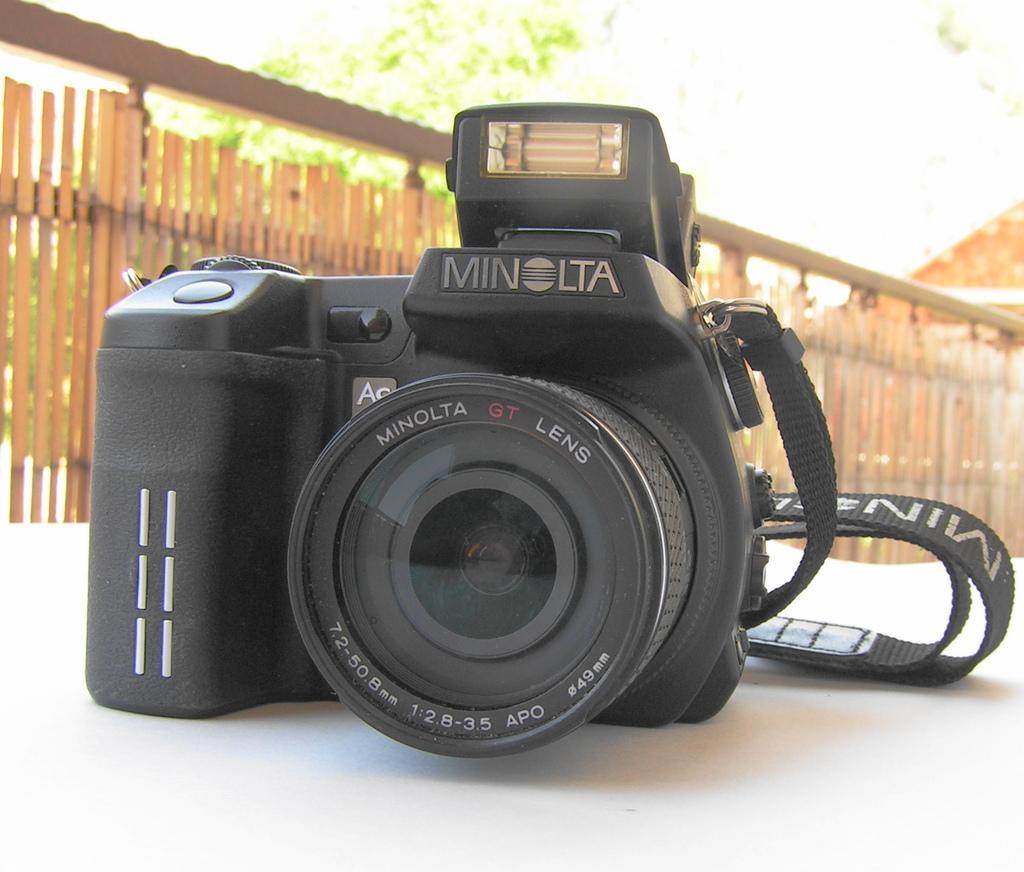Can you describe this image briefly? In this image we can see a camera on the white color surface. In the background, we can see a wooden boundary and a tree. 